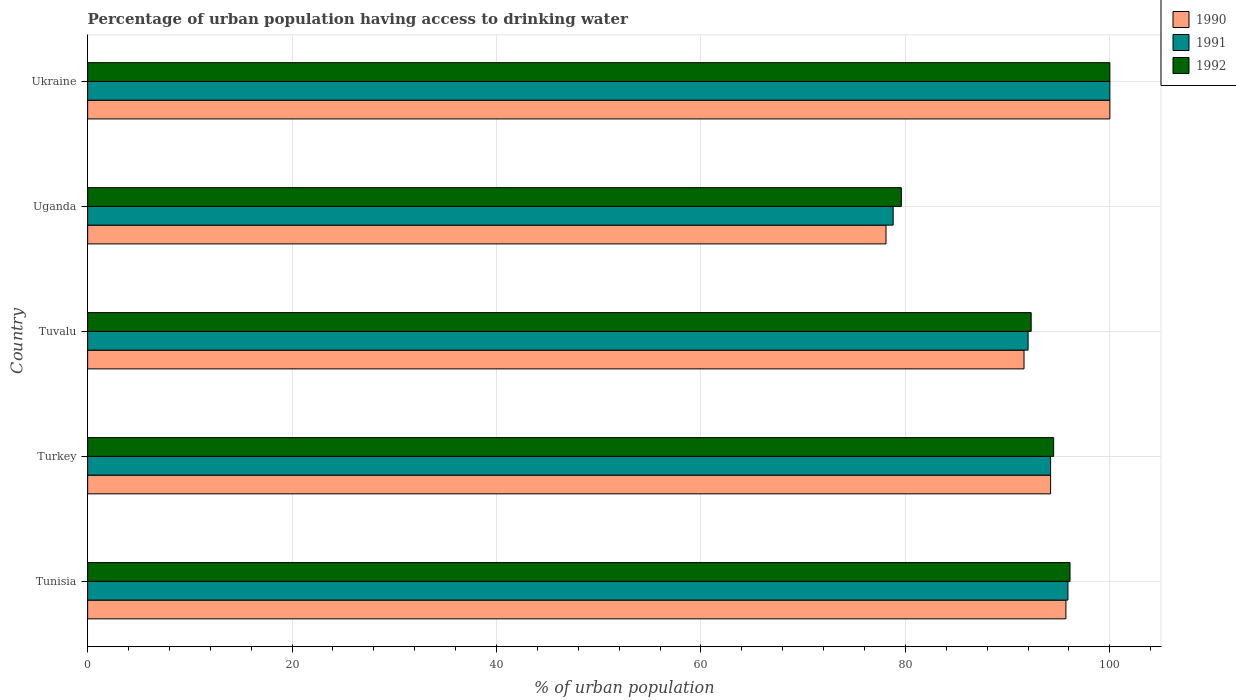How many groups of bars are there?
Keep it short and to the point. 5. Are the number of bars per tick equal to the number of legend labels?
Offer a terse response. Yes. How many bars are there on the 1st tick from the bottom?
Provide a short and direct response. 3. What is the label of the 2nd group of bars from the top?
Provide a short and direct response. Uganda. Across all countries, what is the maximum percentage of urban population having access to drinking water in 1992?
Your response must be concise. 100. Across all countries, what is the minimum percentage of urban population having access to drinking water in 1991?
Ensure brevity in your answer.  78.8. In which country was the percentage of urban population having access to drinking water in 1992 maximum?
Ensure brevity in your answer.  Ukraine. In which country was the percentage of urban population having access to drinking water in 1991 minimum?
Offer a very short reply. Uganda. What is the total percentage of urban population having access to drinking water in 1992 in the graph?
Your answer should be compact. 462.5. What is the difference between the percentage of urban population having access to drinking water in 1992 in Turkey and that in Tuvalu?
Provide a succinct answer. 2.2. What is the difference between the percentage of urban population having access to drinking water in 1992 in Tuvalu and the percentage of urban population having access to drinking water in 1991 in Tunisia?
Offer a very short reply. -3.6. What is the average percentage of urban population having access to drinking water in 1992 per country?
Your answer should be compact. 92.5. What is the difference between the percentage of urban population having access to drinking water in 1990 and percentage of urban population having access to drinking water in 1992 in Tunisia?
Ensure brevity in your answer.  -0.4. In how many countries, is the percentage of urban population having access to drinking water in 1991 greater than 64 %?
Provide a succinct answer. 5. What is the ratio of the percentage of urban population having access to drinking water in 1990 in Tuvalu to that in Ukraine?
Your response must be concise. 0.92. Is the percentage of urban population having access to drinking water in 1991 in Uganda less than that in Ukraine?
Your answer should be compact. Yes. What is the difference between the highest and the second highest percentage of urban population having access to drinking water in 1990?
Keep it short and to the point. 4.3. What is the difference between the highest and the lowest percentage of urban population having access to drinking water in 1991?
Give a very brief answer. 21.2. In how many countries, is the percentage of urban population having access to drinking water in 1990 greater than the average percentage of urban population having access to drinking water in 1990 taken over all countries?
Give a very brief answer. 3. What does the 1st bar from the top in Ukraine represents?
Ensure brevity in your answer.  1992. Are all the bars in the graph horizontal?
Provide a short and direct response. Yes. How many countries are there in the graph?
Give a very brief answer. 5. What is the difference between two consecutive major ticks on the X-axis?
Provide a short and direct response. 20. Are the values on the major ticks of X-axis written in scientific E-notation?
Make the answer very short. No. Does the graph contain any zero values?
Your answer should be very brief. No. Where does the legend appear in the graph?
Offer a very short reply. Top right. How many legend labels are there?
Ensure brevity in your answer.  3. What is the title of the graph?
Ensure brevity in your answer.  Percentage of urban population having access to drinking water. Does "1969" appear as one of the legend labels in the graph?
Offer a terse response. No. What is the label or title of the X-axis?
Give a very brief answer. % of urban population. What is the label or title of the Y-axis?
Offer a terse response. Country. What is the % of urban population in 1990 in Tunisia?
Keep it short and to the point. 95.7. What is the % of urban population in 1991 in Tunisia?
Your answer should be very brief. 95.9. What is the % of urban population of 1992 in Tunisia?
Ensure brevity in your answer.  96.1. What is the % of urban population in 1990 in Turkey?
Your answer should be compact. 94.2. What is the % of urban population in 1991 in Turkey?
Provide a succinct answer. 94.2. What is the % of urban population of 1992 in Turkey?
Your response must be concise. 94.5. What is the % of urban population in 1990 in Tuvalu?
Provide a short and direct response. 91.6. What is the % of urban population in 1991 in Tuvalu?
Offer a very short reply. 92. What is the % of urban population of 1992 in Tuvalu?
Your answer should be compact. 92.3. What is the % of urban population in 1990 in Uganda?
Provide a short and direct response. 78.1. What is the % of urban population of 1991 in Uganda?
Offer a terse response. 78.8. What is the % of urban population of 1992 in Uganda?
Make the answer very short. 79.6. What is the % of urban population in 1991 in Ukraine?
Your response must be concise. 100. What is the % of urban population of 1992 in Ukraine?
Provide a short and direct response. 100. Across all countries, what is the minimum % of urban population in 1990?
Make the answer very short. 78.1. Across all countries, what is the minimum % of urban population in 1991?
Offer a very short reply. 78.8. Across all countries, what is the minimum % of urban population in 1992?
Offer a very short reply. 79.6. What is the total % of urban population of 1990 in the graph?
Offer a terse response. 459.6. What is the total % of urban population in 1991 in the graph?
Your answer should be very brief. 460.9. What is the total % of urban population in 1992 in the graph?
Offer a terse response. 462.5. What is the difference between the % of urban population in 1990 in Tunisia and that in Turkey?
Offer a terse response. 1.5. What is the difference between the % of urban population of 1992 in Tunisia and that in Turkey?
Provide a succinct answer. 1.6. What is the difference between the % of urban population of 1991 in Tunisia and that in Tuvalu?
Offer a terse response. 3.9. What is the difference between the % of urban population in 1992 in Tunisia and that in Tuvalu?
Provide a succinct answer. 3.8. What is the difference between the % of urban population in 1990 in Tunisia and that in Uganda?
Make the answer very short. 17.6. What is the difference between the % of urban population of 1991 in Tunisia and that in Ukraine?
Your answer should be very brief. -4.1. What is the difference between the % of urban population of 1992 in Tunisia and that in Ukraine?
Ensure brevity in your answer.  -3.9. What is the difference between the % of urban population of 1992 in Turkey and that in Tuvalu?
Your answer should be very brief. 2.2. What is the difference between the % of urban population of 1992 in Turkey and that in Uganda?
Your response must be concise. 14.9. What is the difference between the % of urban population of 1991 in Turkey and that in Ukraine?
Your response must be concise. -5.8. What is the difference between the % of urban population in 1992 in Turkey and that in Ukraine?
Your answer should be compact. -5.5. What is the difference between the % of urban population of 1991 in Tuvalu and that in Uganda?
Make the answer very short. 13.2. What is the difference between the % of urban population of 1992 in Tuvalu and that in Uganda?
Your answer should be compact. 12.7. What is the difference between the % of urban population in 1992 in Tuvalu and that in Ukraine?
Give a very brief answer. -7.7. What is the difference between the % of urban population of 1990 in Uganda and that in Ukraine?
Your answer should be compact. -21.9. What is the difference between the % of urban population in 1991 in Uganda and that in Ukraine?
Offer a very short reply. -21.2. What is the difference between the % of urban population in 1992 in Uganda and that in Ukraine?
Offer a terse response. -20.4. What is the difference between the % of urban population in 1990 in Tunisia and the % of urban population in 1992 in Turkey?
Keep it short and to the point. 1.2. What is the difference between the % of urban population in 1990 in Tunisia and the % of urban population in 1991 in Tuvalu?
Keep it short and to the point. 3.7. What is the difference between the % of urban population in 1990 in Tunisia and the % of urban population in 1992 in Tuvalu?
Provide a short and direct response. 3.4. What is the difference between the % of urban population in 1991 in Tunisia and the % of urban population in 1992 in Tuvalu?
Your answer should be very brief. 3.6. What is the difference between the % of urban population in 1990 in Tunisia and the % of urban population in 1991 in Uganda?
Offer a very short reply. 16.9. What is the difference between the % of urban population in 1990 in Tunisia and the % of urban population in 1991 in Ukraine?
Ensure brevity in your answer.  -4.3. What is the difference between the % of urban population in 1991 in Tunisia and the % of urban population in 1992 in Ukraine?
Your answer should be compact. -4.1. What is the difference between the % of urban population in 1991 in Turkey and the % of urban population in 1992 in Tuvalu?
Make the answer very short. 1.9. What is the difference between the % of urban population in 1990 in Turkey and the % of urban population in 1992 in Uganda?
Keep it short and to the point. 14.6. What is the difference between the % of urban population of 1991 in Turkey and the % of urban population of 1992 in Uganda?
Ensure brevity in your answer.  14.6. What is the difference between the % of urban population in 1990 in Turkey and the % of urban population in 1992 in Ukraine?
Your answer should be very brief. -5.8. What is the difference between the % of urban population of 1990 in Tuvalu and the % of urban population of 1992 in Ukraine?
Ensure brevity in your answer.  -8.4. What is the difference between the % of urban population in 1991 in Tuvalu and the % of urban population in 1992 in Ukraine?
Provide a short and direct response. -8. What is the difference between the % of urban population of 1990 in Uganda and the % of urban population of 1991 in Ukraine?
Offer a terse response. -21.9. What is the difference between the % of urban population in 1990 in Uganda and the % of urban population in 1992 in Ukraine?
Provide a short and direct response. -21.9. What is the difference between the % of urban population of 1991 in Uganda and the % of urban population of 1992 in Ukraine?
Make the answer very short. -21.2. What is the average % of urban population of 1990 per country?
Your response must be concise. 91.92. What is the average % of urban population of 1991 per country?
Keep it short and to the point. 92.18. What is the average % of urban population of 1992 per country?
Your response must be concise. 92.5. What is the difference between the % of urban population of 1991 and % of urban population of 1992 in Tunisia?
Ensure brevity in your answer.  -0.2. What is the difference between the % of urban population in 1990 and % of urban population in 1992 in Turkey?
Give a very brief answer. -0.3. What is the difference between the % of urban population of 1990 and % of urban population of 1992 in Tuvalu?
Offer a very short reply. -0.7. What is the difference between the % of urban population of 1991 and % of urban population of 1992 in Tuvalu?
Ensure brevity in your answer.  -0.3. What is the difference between the % of urban population of 1990 and % of urban population of 1991 in Uganda?
Provide a succinct answer. -0.7. What is the difference between the % of urban population of 1990 and % of urban population of 1992 in Uganda?
Ensure brevity in your answer.  -1.5. What is the difference between the % of urban population of 1991 and % of urban population of 1992 in Uganda?
Your answer should be very brief. -0.8. What is the difference between the % of urban population of 1990 and % of urban population of 1991 in Ukraine?
Make the answer very short. 0. What is the difference between the % of urban population in 1990 and % of urban population in 1992 in Ukraine?
Provide a short and direct response. 0. What is the difference between the % of urban population in 1991 and % of urban population in 1992 in Ukraine?
Offer a very short reply. 0. What is the ratio of the % of urban population in 1990 in Tunisia to that in Turkey?
Provide a short and direct response. 1.02. What is the ratio of the % of urban population in 1992 in Tunisia to that in Turkey?
Your answer should be very brief. 1.02. What is the ratio of the % of urban population in 1990 in Tunisia to that in Tuvalu?
Offer a terse response. 1.04. What is the ratio of the % of urban population of 1991 in Tunisia to that in Tuvalu?
Offer a very short reply. 1.04. What is the ratio of the % of urban population of 1992 in Tunisia to that in Tuvalu?
Your answer should be compact. 1.04. What is the ratio of the % of urban population of 1990 in Tunisia to that in Uganda?
Offer a terse response. 1.23. What is the ratio of the % of urban population in 1991 in Tunisia to that in Uganda?
Offer a terse response. 1.22. What is the ratio of the % of urban population of 1992 in Tunisia to that in Uganda?
Ensure brevity in your answer.  1.21. What is the ratio of the % of urban population of 1990 in Tunisia to that in Ukraine?
Your answer should be compact. 0.96. What is the ratio of the % of urban population of 1991 in Tunisia to that in Ukraine?
Your answer should be compact. 0.96. What is the ratio of the % of urban population of 1990 in Turkey to that in Tuvalu?
Your response must be concise. 1.03. What is the ratio of the % of urban population in 1991 in Turkey to that in Tuvalu?
Your answer should be compact. 1.02. What is the ratio of the % of urban population of 1992 in Turkey to that in Tuvalu?
Offer a terse response. 1.02. What is the ratio of the % of urban population in 1990 in Turkey to that in Uganda?
Your response must be concise. 1.21. What is the ratio of the % of urban population in 1991 in Turkey to that in Uganda?
Provide a succinct answer. 1.2. What is the ratio of the % of urban population of 1992 in Turkey to that in Uganda?
Make the answer very short. 1.19. What is the ratio of the % of urban population of 1990 in Turkey to that in Ukraine?
Give a very brief answer. 0.94. What is the ratio of the % of urban population in 1991 in Turkey to that in Ukraine?
Keep it short and to the point. 0.94. What is the ratio of the % of urban population of 1992 in Turkey to that in Ukraine?
Keep it short and to the point. 0.94. What is the ratio of the % of urban population of 1990 in Tuvalu to that in Uganda?
Your answer should be very brief. 1.17. What is the ratio of the % of urban population in 1991 in Tuvalu to that in Uganda?
Provide a succinct answer. 1.17. What is the ratio of the % of urban population of 1992 in Tuvalu to that in Uganda?
Your answer should be compact. 1.16. What is the ratio of the % of urban population of 1990 in Tuvalu to that in Ukraine?
Your response must be concise. 0.92. What is the ratio of the % of urban population in 1992 in Tuvalu to that in Ukraine?
Ensure brevity in your answer.  0.92. What is the ratio of the % of urban population of 1990 in Uganda to that in Ukraine?
Provide a succinct answer. 0.78. What is the ratio of the % of urban population of 1991 in Uganda to that in Ukraine?
Provide a succinct answer. 0.79. What is the ratio of the % of urban population in 1992 in Uganda to that in Ukraine?
Make the answer very short. 0.8. What is the difference between the highest and the second highest % of urban population of 1991?
Keep it short and to the point. 4.1. What is the difference between the highest and the second highest % of urban population of 1992?
Offer a terse response. 3.9. What is the difference between the highest and the lowest % of urban population in 1990?
Make the answer very short. 21.9. What is the difference between the highest and the lowest % of urban population of 1991?
Offer a very short reply. 21.2. What is the difference between the highest and the lowest % of urban population of 1992?
Make the answer very short. 20.4. 